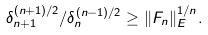Convert formula to latex. <formula><loc_0><loc_0><loc_500><loc_500>\delta _ { n + 1 } ^ { ( n + 1 ) / 2 } / \delta _ { n } ^ { ( n - 1 ) / 2 } \geq \| F _ { n } \| _ { E } ^ { 1 / n } .</formula> 